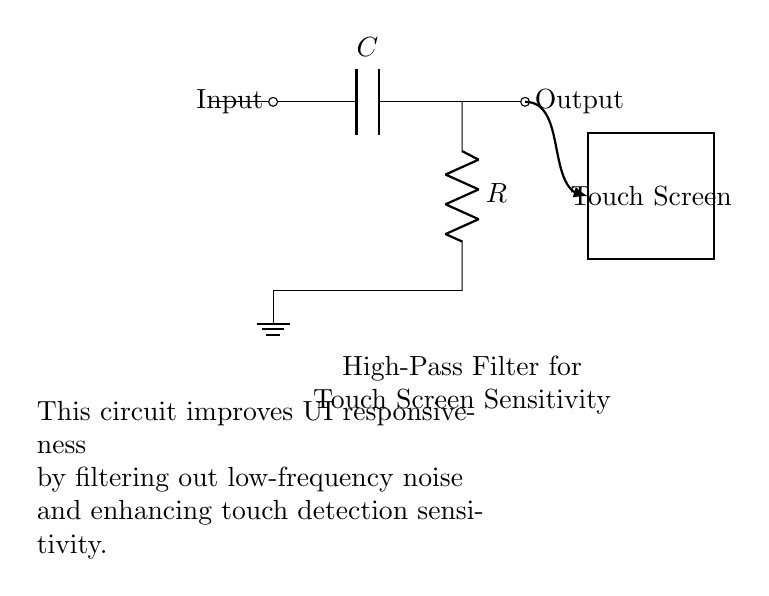What does the capacitor in this circuit do? The capacitor blocks low-frequency signals, allowing high-frequency signals to pass through. This is a key feature of a high-pass filter.
Answer: Blocks low-frequency signals What is the function of the resistor in this high-pass filter? The resistor, in combination with the capacitor, determines the cut-off frequency of the filter. This cut-off frequency is where the filter begins to attenuate lower frequencies.
Answer: Determines cut-off frequency What is the output of the circuit connected to? The output is connected to the touch screen, which benefits from enhanced responsiveness due to the filtering effect of the circuit.
Answer: Touch screen How does this circuit improve touch screen sensitivity? By filtering out low-frequency noise, the circuit enhances the detection of touch events, making the user interface more responsive.
Answer: Enhances touch detection What is the main purpose of this circuit? The main purpose is to improve user interface responsiveness through effective noise filtering, specifically to adjust touch screen sensitivity.
Answer: Improve UI responsiveness What happens to low-frequency signals in this circuit? Low-frequency signals are attenuated or blocked, allowing only high-frequency signals to pass through to the output.
Answer: Attenuated or blocked 